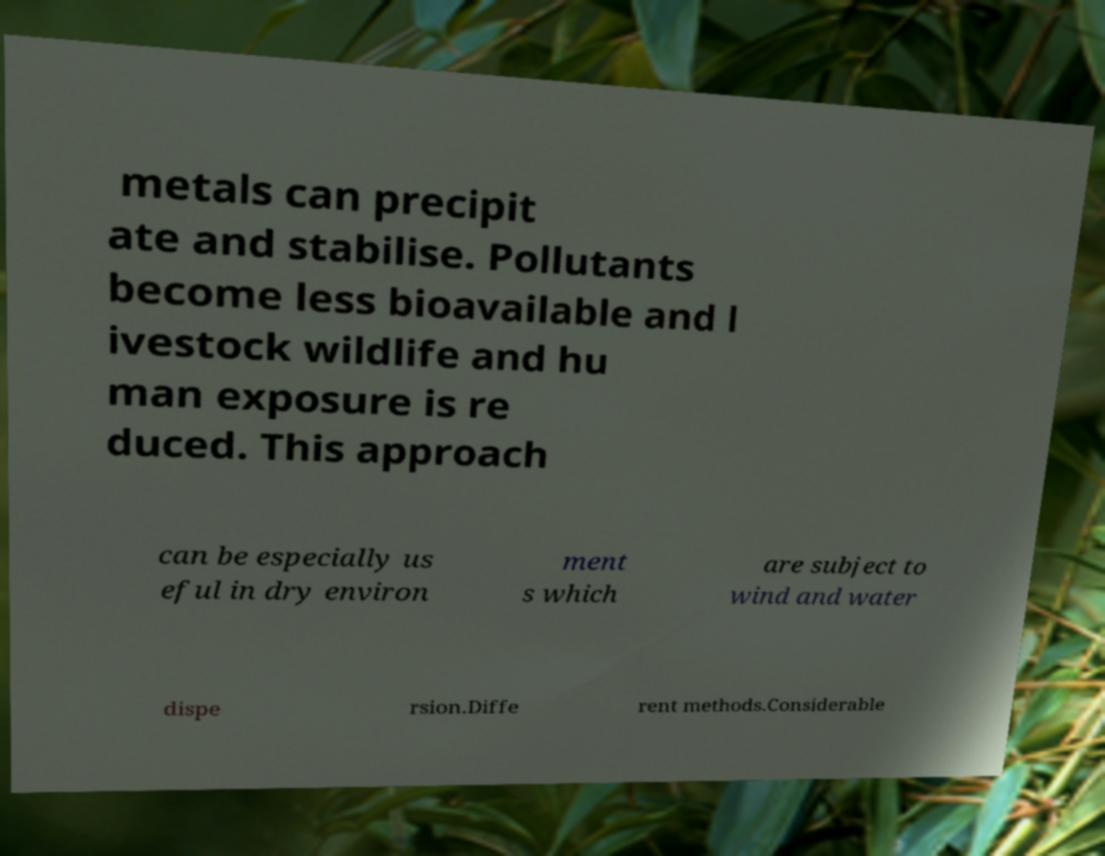Please identify and transcribe the text found in this image. metals can precipit ate and stabilise. Pollutants become less bioavailable and l ivestock wildlife and hu man exposure is re duced. This approach can be especially us eful in dry environ ment s which are subject to wind and water dispe rsion.Diffe rent methods.Considerable 